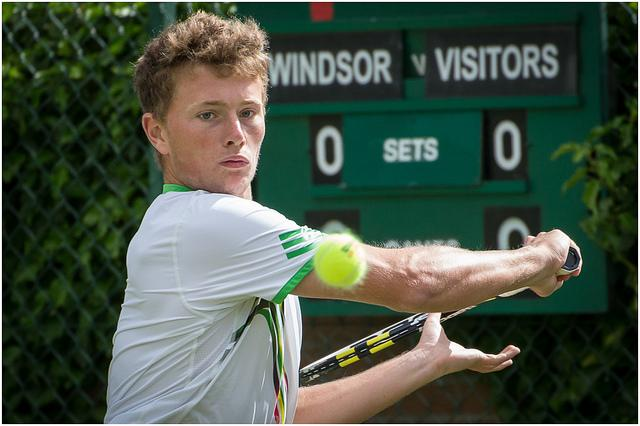Someone needs to score at least how many sets to win? Please explain your reasoning. two. A team or players needs that amount to win at tennis. 